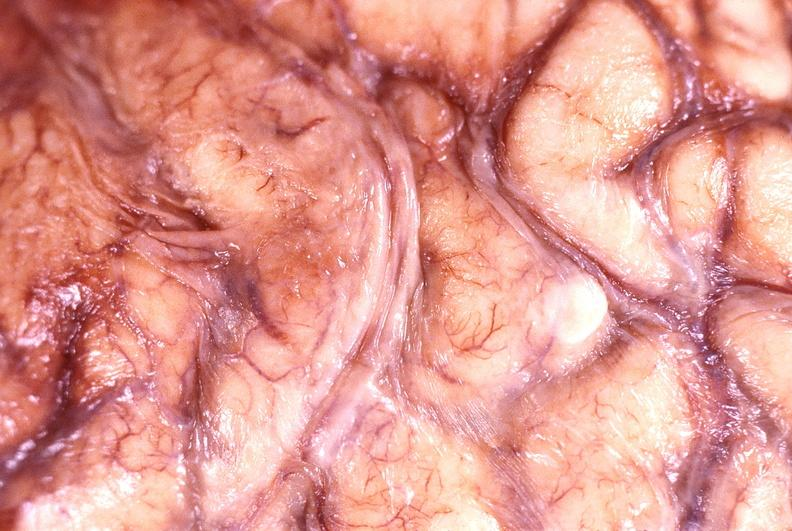does stillborn macerated show brain abscess?
Answer the question using a single word or phrase. No 